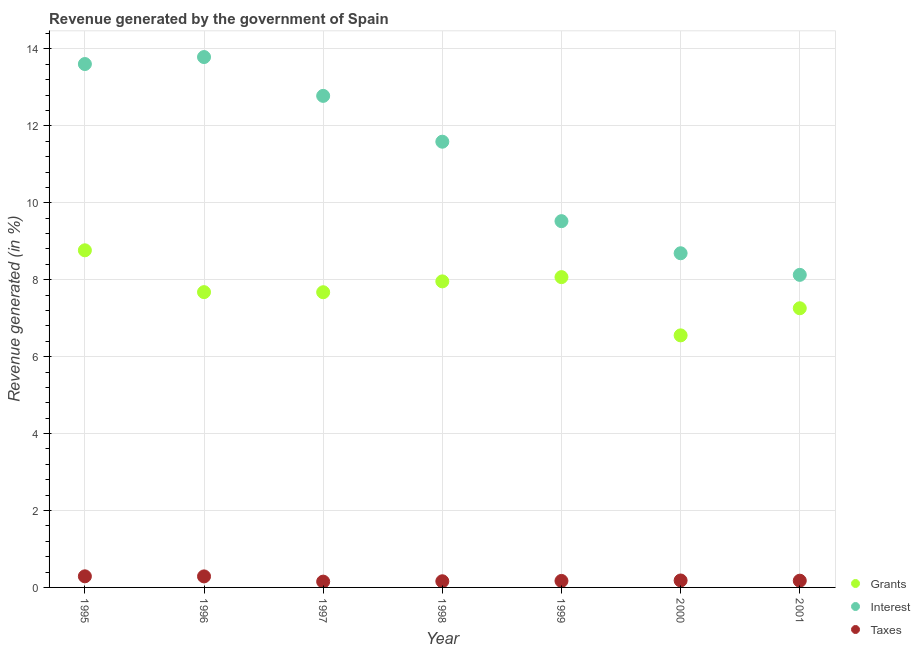How many different coloured dotlines are there?
Your response must be concise. 3. Is the number of dotlines equal to the number of legend labels?
Your answer should be very brief. Yes. What is the percentage of revenue generated by grants in 1998?
Give a very brief answer. 7.96. Across all years, what is the maximum percentage of revenue generated by taxes?
Offer a terse response. 0.29. Across all years, what is the minimum percentage of revenue generated by interest?
Your response must be concise. 8.13. In which year was the percentage of revenue generated by grants maximum?
Make the answer very short. 1995. What is the total percentage of revenue generated by interest in the graph?
Keep it short and to the point. 78.1. What is the difference between the percentage of revenue generated by taxes in 1995 and that in 1997?
Keep it short and to the point. 0.14. What is the difference between the percentage of revenue generated by taxes in 2000 and the percentage of revenue generated by grants in 1998?
Provide a succinct answer. -7.78. What is the average percentage of revenue generated by grants per year?
Your answer should be very brief. 7.71. In the year 1999, what is the difference between the percentage of revenue generated by taxes and percentage of revenue generated by grants?
Your answer should be very brief. -7.9. In how many years, is the percentage of revenue generated by interest greater than 9.2 %?
Your response must be concise. 5. What is the ratio of the percentage of revenue generated by grants in 1995 to that in 1996?
Provide a short and direct response. 1.14. What is the difference between the highest and the second highest percentage of revenue generated by grants?
Your answer should be very brief. 0.7. What is the difference between the highest and the lowest percentage of revenue generated by interest?
Give a very brief answer. 5.66. In how many years, is the percentage of revenue generated by interest greater than the average percentage of revenue generated by interest taken over all years?
Provide a short and direct response. 4. Is the sum of the percentage of revenue generated by taxes in 1997 and 2000 greater than the maximum percentage of revenue generated by interest across all years?
Offer a terse response. No. Does the percentage of revenue generated by grants monotonically increase over the years?
Your answer should be very brief. No. How many years are there in the graph?
Keep it short and to the point. 7. Are the values on the major ticks of Y-axis written in scientific E-notation?
Offer a very short reply. No. Does the graph contain grids?
Your answer should be compact. Yes. Where does the legend appear in the graph?
Give a very brief answer. Bottom right. How many legend labels are there?
Give a very brief answer. 3. What is the title of the graph?
Offer a terse response. Revenue generated by the government of Spain. What is the label or title of the X-axis?
Your answer should be compact. Year. What is the label or title of the Y-axis?
Provide a succinct answer. Revenue generated (in %). What is the Revenue generated (in %) in Grants in 1995?
Offer a very short reply. 8.77. What is the Revenue generated (in %) of Interest in 1995?
Your answer should be very brief. 13.61. What is the Revenue generated (in %) of Taxes in 1995?
Make the answer very short. 0.29. What is the Revenue generated (in %) of Grants in 1996?
Give a very brief answer. 7.68. What is the Revenue generated (in %) of Interest in 1996?
Make the answer very short. 13.79. What is the Revenue generated (in %) of Taxes in 1996?
Provide a short and direct response. 0.29. What is the Revenue generated (in %) of Grants in 1997?
Give a very brief answer. 7.67. What is the Revenue generated (in %) of Interest in 1997?
Offer a terse response. 12.78. What is the Revenue generated (in %) of Taxes in 1997?
Offer a very short reply. 0.15. What is the Revenue generated (in %) in Grants in 1998?
Give a very brief answer. 7.96. What is the Revenue generated (in %) in Interest in 1998?
Offer a very short reply. 11.59. What is the Revenue generated (in %) in Taxes in 1998?
Your response must be concise. 0.16. What is the Revenue generated (in %) of Grants in 1999?
Your answer should be very brief. 8.07. What is the Revenue generated (in %) of Interest in 1999?
Ensure brevity in your answer.  9.52. What is the Revenue generated (in %) of Taxes in 1999?
Your response must be concise. 0.17. What is the Revenue generated (in %) of Grants in 2000?
Your answer should be very brief. 6.55. What is the Revenue generated (in %) of Interest in 2000?
Keep it short and to the point. 8.69. What is the Revenue generated (in %) of Taxes in 2000?
Ensure brevity in your answer.  0.18. What is the Revenue generated (in %) of Grants in 2001?
Give a very brief answer. 7.26. What is the Revenue generated (in %) of Interest in 2001?
Give a very brief answer. 8.13. What is the Revenue generated (in %) of Taxes in 2001?
Give a very brief answer. 0.17. Across all years, what is the maximum Revenue generated (in %) of Grants?
Offer a very short reply. 8.77. Across all years, what is the maximum Revenue generated (in %) in Interest?
Your answer should be very brief. 13.79. Across all years, what is the maximum Revenue generated (in %) in Taxes?
Provide a short and direct response. 0.29. Across all years, what is the minimum Revenue generated (in %) of Grants?
Offer a terse response. 6.55. Across all years, what is the minimum Revenue generated (in %) of Interest?
Your answer should be very brief. 8.13. Across all years, what is the minimum Revenue generated (in %) of Taxes?
Offer a terse response. 0.15. What is the total Revenue generated (in %) of Grants in the graph?
Provide a succinct answer. 53.95. What is the total Revenue generated (in %) in Interest in the graph?
Your answer should be very brief. 78.1. What is the total Revenue generated (in %) of Taxes in the graph?
Your answer should be very brief. 1.41. What is the difference between the Revenue generated (in %) of Grants in 1995 and that in 1996?
Give a very brief answer. 1.09. What is the difference between the Revenue generated (in %) of Interest in 1995 and that in 1996?
Your response must be concise. -0.18. What is the difference between the Revenue generated (in %) of Taxes in 1995 and that in 1996?
Provide a short and direct response. 0. What is the difference between the Revenue generated (in %) of Grants in 1995 and that in 1997?
Offer a terse response. 1.09. What is the difference between the Revenue generated (in %) of Interest in 1995 and that in 1997?
Your answer should be compact. 0.83. What is the difference between the Revenue generated (in %) in Taxes in 1995 and that in 1997?
Your response must be concise. 0.14. What is the difference between the Revenue generated (in %) in Grants in 1995 and that in 1998?
Ensure brevity in your answer.  0.81. What is the difference between the Revenue generated (in %) of Interest in 1995 and that in 1998?
Offer a very short reply. 2.02. What is the difference between the Revenue generated (in %) of Taxes in 1995 and that in 1998?
Your answer should be compact. 0.13. What is the difference between the Revenue generated (in %) in Grants in 1995 and that in 1999?
Keep it short and to the point. 0.7. What is the difference between the Revenue generated (in %) of Interest in 1995 and that in 1999?
Make the answer very short. 4.08. What is the difference between the Revenue generated (in %) in Taxes in 1995 and that in 1999?
Provide a succinct answer. 0.12. What is the difference between the Revenue generated (in %) in Grants in 1995 and that in 2000?
Your answer should be compact. 2.21. What is the difference between the Revenue generated (in %) of Interest in 1995 and that in 2000?
Ensure brevity in your answer.  4.92. What is the difference between the Revenue generated (in %) of Taxes in 1995 and that in 2000?
Keep it short and to the point. 0.11. What is the difference between the Revenue generated (in %) of Grants in 1995 and that in 2001?
Offer a terse response. 1.51. What is the difference between the Revenue generated (in %) of Interest in 1995 and that in 2001?
Ensure brevity in your answer.  5.48. What is the difference between the Revenue generated (in %) of Taxes in 1995 and that in 2001?
Keep it short and to the point. 0.11. What is the difference between the Revenue generated (in %) in Grants in 1996 and that in 1997?
Ensure brevity in your answer.  0. What is the difference between the Revenue generated (in %) of Interest in 1996 and that in 1997?
Offer a very short reply. 1.01. What is the difference between the Revenue generated (in %) in Taxes in 1996 and that in 1997?
Make the answer very short. 0.14. What is the difference between the Revenue generated (in %) of Grants in 1996 and that in 1998?
Ensure brevity in your answer.  -0.28. What is the difference between the Revenue generated (in %) in Interest in 1996 and that in 1998?
Your answer should be compact. 2.2. What is the difference between the Revenue generated (in %) of Taxes in 1996 and that in 1998?
Offer a terse response. 0.13. What is the difference between the Revenue generated (in %) in Grants in 1996 and that in 1999?
Provide a succinct answer. -0.39. What is the difference between the Revenue generated (in %) of Interest in 1996 and that in 1999?
Offer a very short reply. 4.27. What is the difference between the Revenue generated (in %) in Taxes in 1996 and that in 1999?
Your response must be concise. 0.12. What is the difference between the Revenue generated (in %) in Grants in 1996 and that in 2000?
Your answer should be very brief. 1.12. What is the difference between the Revenue generated (in %) in Interest in 1996 and that in 2000?
Offer a terse response. 5.1. What is the difference between the Revenue generated (in %) of Taxes in 1996 and that in 2000?
Ensure brevity in your answer.  0.11. What is the difference between the Revenue generated (in %) of Grants in 1996 and that in 2001?
Ensure brevity in your answer.  0.42. What is the difference between the Revenue generated (in %) in Interest in 1996 and that in 2001?
Give a very brief answer. 5.66. What is the difference between the Revenue generated (in %) in Taxes in 1996 and that in 2001?
Ensure brevity in your answer.  0.11. What is the difference between the Revenue generated (in %) of Grants in 1997 and that in 1998?
Your answer should be compact. -0.28. What is the difference between the Revenue generated (in %) in Interest in 1997 and that in 1998?
Offer a very short reply. 1.19. What is the difference between the Revenue generated (in %) of Taxes in 1997 and that in 1998?
Keep it short and to the point. -0.01. What is the difference between the Revenue generated (in %) of Grants in 1997 and that in 1999?
Your answer should be very brief. -0.39. What is the difference between the Revenue generated (in %) of Interest in 1997 and that in 1999?
Ensure brevity in your answer.  3.26. What is the difference between the Revenue generated (in %) of Taxes in 1997 and that in 1999?
Your answer should be compact. -0.02. What is the difference between the Revenue generated (in %) of Grants in 1997 and that in 2000?
Your answer should be very brief. 1.12. What is the difference between the Revenue generated (in %) in Interest in 1997 and that in 2000?
Provide a succinct answer. 4.09. What is the difference between the Revenue generated (in %) in Taxes in 1997 and that in 2000?
Ensure brevity in your answer.  -0.03. What is the difference between the Revenue generated (in %) in Grants in 1997 and that in 2001?
Give a very brief answer. 0.42. What is the difference between the Revenue generated (in %) in Interest in 1997 and that in 2001?
Make the answer very short. 4.65. What is the difference between the Revenue generated (in %) of Taxes in 1997 and that in 2001?
Provide a succinct answer. -0.02. What is the difference between the Revenue generated (in %) of Grants in 1998 and that in 1999?
Your answer should be very brief. -0.11. What is the difference between the Revenue generated (in %) of Interest in 1998 and that in 1999?
Offer a terse response. 2.07. What is the difference between the Revenue generated (in %) of Taxes in 1998 and that in 1999?
Ensure brevity in your answer.  -0.01. What is the difference between the Revenue generated (in %) of Grants in 1998 and that in 2000?
Your answer should be very brief. 1.4. What is the difference between the Revenue generated (in %) of Interest in 1998 and that in 2000?
Keep it short and to the point. 2.9. What is the difference between the Revenue generated (in %) in Taxes in 1998 and that in 2000?
Offer a very short reply. -0.02. What is the difference between the Revenue generated (in %) of Grants in 1998 and that in 2001?
Make the answer very short. 0.7. What is the difference between the Revenue generated (in %) of Interest in 1998 and that in 2001?
Give a very brief answer. 3.46. What is the difference between the Revenue generated (in %) in Taxes in 1998 and that in 2001?
Your response must be concise. -0.01. What is the difference between the Revenue generated (in %) in Grants in 1999 and that in 2000?
Ensure brevity in your answer.  1.51. What is the difference between the Revenue generated (in %) in Interest in 1999 and that in 2000?
Provide a short and direct response. 0.83. What is the difference between the Revenue generated (in %) in Taxes in 1999 and that in 2000?
Your response must be concise. -0.01. What is the difference between the Revenue generated (in %) in Grants in 1999 and that in 2001?
Offer a very short reply. 0.81. What is the difference between the Revenue generated (in %) in Interest in 1999 and that in 2001?
Offer a very short reply. 1.4. What is the difference between the Revenue generated (in %) in Taxes in 1999 and that in 2001?
Your answer should be compact. -0.01. What is the difference between the Revenue generated (in %) in Grants in 2000 and that in 2001?
Ensure brevity in your answer.  -0.7. What is the difference between the Revenue generated (in %) of Interest in 2000 and that in 2001?
Keep it short and to the point. 0.56. What is the difference between the Revenue generated (in %) in Taxes in 2000 and that in 2001?
Provide a succinct answer. 0.01. What is the difference between the Revenue generated (in %) in Grants in 1995 and the Revenue generated (in %) in Interest in 1996?
Offer a very short reply. -5.02. What is the difference between the Revenue generated (in %) of Grants in 1995 and the Revenue generated (in %) of Taxes in 1996?
Your answer should be very brief. 8.48. What is the difference between the Revenue generated (in %) in Interest in 1995 and the Revenue generated (in %) in Taxes in 1996?
Your answer should be compact. 13.32. What is the difference between the Revenue generated (in %) of Grants in 1995 and the Revenue generated (in %) of Interest in 1997?
Your answer should be compact. -4.02. What is the difference between the Revenue generated (in %) of Grants in 1995 and the Revenue generated (in %) of Taxes in 1997?
Provide a succinct answer. 8.61. What is the difference between the Revenue generated (in %) in Interest in 1995 and the Revenue generated (in %) in Taxes in 1997?
Your response must be concise. 13.46. What is the difference between the Revenue generated (in %) of Grants in 1995 and the Revenue generated (in %) of Interest in 1998?
Your response must be concise. -2.82. What is the difference between the Revenue generated (in %) of Grants in 1995 and the Revenue generated (in %) of Taxes in 1998?
Offer a very short reply. 8.6. What is the difference between the Revenue generated (in %) in Interest in 1995 and the Revenue generated (in %) in Taxes in 1998?
Provide a succinct answer. 13.45. What is the difference between the Revenue generated (in %) of Grants in 1995 and the Revenue generated (in %) of Interest in 1999?
Your response must be concise. -0.76. What is the difference between the Revenue generated (in %) in Grants in 1995 and the Revenue generated (in %) in Taxes in 1999?
Give a very brief answer. 8.6. What is the difference between the Revenue generated (in %) in Interest in 1995 and the Revenue generated (in %) in Taxes in 1999?
Provide a short and direct response. 13.44. What is the difference between the Revenue generated (in %) of Grants in 1995 and the Revenue generated (in %) of Interest in 2000?
Your response must be concise. 0.08. What is the difference between the Revenue generated (in %) in Grants in 1995 and the Revenue generated (in %) in Taxes in 2000?
Make the answer very short. 8.58. What is the difference between the Revenue generated (in %) of Interest in 1995 and the Revenue generated (in %) of Taxes in 2000?
Keep it short and to the point. 13.43. What is the difference between the Revenue generated (in %) of Grants in 1995 and the Revenue generated (in %) of Interest in 2001?
Offer a very short reply. 0.64. What is the difference between the Revenue generated (in %) in Grants in 1995 and the Revenue generated (in %) in Taxes in 2001?
Provide a succinct answer. 8.59. What is the difference between the Revenue generated (in %) of Interest in 1995 and the Revenue generated (in %) of Taxes in 2001?
Your answer should be very brief. 13.43. What is the difference between the Revenue generated (in %) of Grants in 1996 and the Revenue generated (in %) of Interest in 1997?
Provide a succinct answer. -5.1. What is the difference between the Revenue generated (in %) in Grants in 1996 and the Revenue generated (in %) in Taxes in 1997?
Keep it short and to the point. 7.53. What is the difference between the Revenue generated (in %) of Interest in 1996 and the Revenue generated (in %) of Taxes in 1997?
Make the answer very short. 13.64. What is the difference between the Revenue generated (in %) in Grants in 1996 and the Revenue generated (in %) in Interest in 1998?
Your answer should be very brief. -3.91. What is the difference between the Revenue generated (in %) in Grants in 1996 and the Revenue generated (in %) in Taxes in 1998?
Offer a very short reply. 7.52. What is the difference between the Revenue generated (in %) in Interest in 1996 and the Revenue generated (in %) in Taxes in 1998?
Make the answer very short. 13.63. What is the difference between the Revenue generated (in %) of Grants in 1996 and the Revenue generated (in %) of Interest in 1999?
Your response must be concise. -1.85. What is the difference between the Revenue generated (in %) of Grants in 1996 and the Revenue generated (in %) of Taxes in 1999?
Keep it short and to the point. 7.51. What is the difference between the Revenue generated (in %) in Interest in 1996 and the Revenue generated (in %) in Taxes in 1999?
Your answer should be very brief. 13.62. What is the difference between the Revenue generated (in %) of Grants in 1996 and the Revenue generated (in %) of Interest in 2000?
Give a very brief answer. -1.01. What is the difference between the Revenue generated (in %) in Grants in 1996 and the Revenue generated (in %) in Taxes in 2000?
Offer a very short reply. 7.5. What is the difference between the Revenue generated (in %) in Interest in 1996 and the Revenue generated (in %) in Taxes in 2000?
Offer a terse response. 13.61. What is the difference between the Revenue generated (in %) of Grants in 1996 and the Revenue generated (in %) of Interest in 2001?
Make the answer very short. -0.45. What is the difference between the Revenue generated (in %) of Grants in 1996 and the Revenue generated (in %) of Taxes in 2001?
Your response must be concise. 7.5. What is the difference between the Revenue generated (in %) in Interest in 1996 and the Revenue generated (in %) in Taxes in 2001?
Your answer should be very brief. 13.61. What is the difference between the Revenue generated (in %) in Grants in 1997 and the Revenue generated (in %) in Interest in 1998?
Your answer should be very brief. -3.91. What is the difference between the Revenue generated (in %) in Grants in 1997 and the Revenue generated (in %) in Taxes in 1998?
Provide a succinct answer. 7.51. What is the difference between the Revenue generated (in %) in Interest in 1997 and the Revenue generated (in %) in Taxes in 1998?
Give a very brief answer. 12.62. What is the difference between the Revenue generated (in %) of Grants in 1997 and the Revenue generated (in %) of Interest in 1999?
Make the answer very short. -1.85. What is the difference between the Revenue generated (in %) of Grants in 1997 and the Revenue generated (in %) of Taxes in 1999?
Provide a succinct answer. 7.51. What is the difference between the Revenue generated (in %) in Interest in 1997 and the Revenue generated (in %) in Taxes in 1999?
Offer a very short reply. 12.61. What is the difference between the Revenue generated (in %) of Grants in 1997 and the Revenue generated (in %) of Interest in 2000?
Provide a short and direct response. -1.01. What is the difference between the Revenue generated (in %) of Grants in 1997 and the Revenue generated (in %) of Taxes in 2000?
Provide a succinct answer. 7.49. What is the difference between the Revenue generated (in %) of Interest in 1997 and the Revenue generated (in %) of Taxes in 2000?
Your answer should be very brief. 12.6. What is the difference between the Revenue generated (in %) in Grants in 1997 and the Revenue generated (in %) in Interest in 2001?
Offer a very short reply. -0.45. What is the difference between the Revenue generated (in %) of Grants in 1997 and the Revenue generated (in %) of Taxes in 2001?
Your answer should be very brief. 7.5. What is the difference between the Revenue generated (in %) in Interest in 1997 and the Revenue generated (in %) in Taxes in 2001?
Make the answer very short. 12.61. What is the difference between the Revenue generated (in %) of Grants in 1998 and the Revenue generated (in %) of Interest in 1999?
Make the answer very short. -1.57. What is the difference between the Revenue generated (in %) of Grants in 1998 and the Revenue generated (in %) of Taxes in 1999?
Make the answer very short. 7.79. What is the difference between the Revenue generated (in %) of Interest in 1998 and the Revenue generated (in %) of Taxes in 1999?
Ensure brevity in your answer.  11.42. What is the difference between the Revenue generated (in %) in Grants in 1998 and the Revenue generated (in %) in Interest in 2000?
Provide a succinct answer. -0.73. What is the difference between the Revenue generated (in %) in Grants in 1998 and the Revenue generated (in %) in Taxes in 2000?
Provide a succinct answer. 7.78. What is the difference between the Revenue generated (in %) of Interest in 1998 and the Revenue generated (in %) of Taxes in 2000?
Your response must be concise. 11.41. What is the difference between the Revenue generated (in %) in Grants in 1998 and the Revenue generated (in %) in Interest in 2001?
Make the answer very short. -0.17. What is the difference between the Revenue generated (in %) of Grants in 1998 and the Revenue generated (in %) of Taxes in 2001?
Your answer should be very brief. 7.78. What is the difference between the Revenue generated (in %) in Interest in 1998 and the Revenue generated (in %) in Taxes in 2001?
Make the answer very short. 11.41. What is the difference between the Revenue generated (in %) in Grants in 1999 and the Revenue generated (in %) in Interest in 2000?
Offer a very short reply. -0.62. What is the difference between the Revenue generated (in %) of Grants in 1999 and the Revenue generated (in %) of Taxes in 2000?
Give a very brief answer. 7.89. What is the difference between the Revenue generated (in %) of Interest in 1999 and the Revenue generated (in %) of Taxes in 2000?
Provide a short and direct response. 9.34. What is the difference between the Revenue generated (in %) of Grants in 1999 and the Revenue generated (in %) of Interest in 2001?
Your answer should be very brief. -0.06. What is the difference between the Revenue generated (in %) of Grants in 1999 and the Revenue generated (in %) of Taxes in 2001?
Make the answer very short. 7.89. What is the difference between the Revenue generated (in %) of Interest in 1999 and the Revenue generated (in %) of Taxes in 2001?
Your response must be concise. 9.35. What is the difference between the Revenue generated (in %) in Grants in 2000 and the Revenue generated (in %) in Interest in 2001?
Your answer should be compact. -1.57. What is the difference between the Revenue generated (in %) of Grants in 2000 and the Revenue generated (in %) of Taxes in 2001?
Your answer should be compact. 6.38. What is the difference between the Revenue generated (in %) of Interest in 2000 and the Revenue generated (in %) of Taxes in 2001?
Offer a very short reply. 8.51. What is the average Revenue generated (in %) of Grants per year?
Offer a terse response. 7.71. What is the average Revenue generated (in %) of Interest per year?
Provide a succinct answer. 11.16. What is the average Revenue generated (in %) in Taxes per year?
Provide a succinct answer. 0.2. In the year 1995, what is the difference between the Revenue generated (in %) of Grants and Revenue generated (in %) of Interest?
Give a very brief answer. -4.84. In the year 1995, what is the difference between the Revenue generated (in %) in Grants and Revenue generated (in %) in Taxes?
Provide a short and direct response. 8.48. In the year 1995, what is the difference between the Revenue generated (in %) of Interest and Revenue generated (in %) of Taxes?
Offer a very short reply. 13.32. In the year 1996, what is the difference between the Revenue generated (in %) of Grants and Revenue generated (in %) of Interest?
Offer a terse response. -6.11. In the year 1996, what is the difference between the Revenue generated (in %) in Grants and Revenue generated (in %) in Taxes?
Offer a very short reply. 7.39. In the year 1996, what is the difference between the Revenue generated (in %) in Interest and Revenue generated (in %) in Taxes?
Offer a very short reply. 13.5. In the year 1997, what is the difference between the Revenue generated (in %) in Grants and Revenue generated (in %) in Interest?
Provide a succinct answer. -5.11. In the year 1997, what is the difference between the Revenue generated (in %) in Grants and Revenue generated (in %) in Taxes?
Give a very brief answer. 7.52. In the year 1997, what is the difference between the Revenue generated (in %) of Interest and Revenue generated (in %) of Taxes?
Give a very brief answer. 12.63. In the year 1998, what is the difference between the Revenue generated (in %) in Grants and Revenue generated (in %) in Interest?
Give a very brief answer. -3.63. In the year 1998, what is the difference between the Revenue generated (in %) of Grants and Revenue generated (in %) of Taxes?
Provide a succinct answer. 7.8. In the year 1998, what is the difference between the Revenue generated (in %) of Interest and Revenue generated (in %) of Taxes?
Offer a terse response. 11.43. In the year 1999, what is the difference between the Revenue generated (in %) in Grants and Revenue generated (in %) in Interest?
Your response must be concise. -1.46. In the year 1999, what is the difference between the Revenue generated (in %) in Grants and Revenue generated (in %) in Taxes?
Keep it short and to the point. 7.9. In the year 1999, what is the difference between the Revenue generated (in %) in Interest and Revenue generated (in %) in Taxes?
Ensure brevity in your answer.  9.35. In the year 2000, what is the difference between the Revenue generated (in %) in Grants and Revenue generated (in %) in Interest?
Your answer should be compact. -2.13. In the year 2000, what is the difference between the Revenue generated (in %) in Grants and Revenue generated (in %) in Taxes?
Your answer should be very brief. 6.37. In the year 2000, what is the difference between the Revenue generated (in %) of Interest and Revenue generated (in %) of Taxes?
Provide a short and direct response. 8.51. In the year 2001, what is the difference between the Revenue generated (in %) in Grants and Revenue generated (in %) in Interest?
Keep it short and to the point. -0.87. In the year 2001, what is the difference between the Revenue generated (in %) of Grants and Revenue generated (in %) of Taxes?
Provide a short and direct response. 7.08. In the year 2001, what is the difference between the Revenue generated (in %) of Interest and Revenue generated (in %) of Taxes?
Offer a very short reply. 7.95. What is the ratio of the Revenue generated (in %) in Grants in 1995 to that in 1996?
Give a very brief answer. 1.14. What is the ratio of the Revenue generated (in %) of Taxes in 1995 to that in 1996?
Offer a very short reply. 1.01. What is the ratio of the Revenue generated (in %) in Grants in 1995 to that in 1997?
Your answer should be very brief. 1.14. What is the ratio of the Revenue generated (in %) of Interest in 1995 to that in 1997?
Provide a succinct answer. 1.06. What is the ratio of the Revenue generated (in %) in Taxes in 1995 to that in 1997?
Make the answer very short. 1.91. What is the ratio of the Revenue generated (in %) of Grants in 1995 to that in 1998?
Keep it short and to the point. 1.1. What is the ratio of the Revenue generated (in %) in Interest in 1995 to that in 1998?
Offer a terse response. 1.17. What is the ratio of the Revenue generated (in %) in Taxes in 1995 to that in 1998?
Your response must be concise. 1.8. What is the ratio of the Revenue generated (in %) of Grants in 1995 to that in 1999?
Keep it short and to the point. 1.09. What is the ratio of the Revenue generated (in %) in Interest in 1995 to that in 1999?
Give a very brief answer. 1.43. What is the ratio of the Revenue generated (in %) in Taxes in 1995 to that in 1999?
Keep it short and to the point. 1.71. What is the ratio of the Revenue generated (in %) of Grants in 1995 to that in 2000?
Your response must be concise. 1.34. What is the ratio of the Revenue generated (in %) of Interest in 1995 to that in 2000?
Your answer should be compact. 1.57. What is the ratio of the Revenue generated (in %) of Taxes in 1995 to that in 2000?
Your answer should be very brief. 1.6. What is the ratio of the Revenue generated (in %) of Grants in 1995 to that in 2001?
Offer a very short reply. 1.21. What is the ratio of the Revenue generated (in %) in Interest in 1995 to that in 2001?
Offer a terse response. 1.67. What is the ratio of the Revenue generated (in %) in Taxes in 1995 to that in 2001?
Provide a short and direct response. 1.65. What is the ratio of the Revenue generated (in %) in Grants in 1996 to that in 1997?
Your answer should be very brief. 1. What is the ratio of the Revenue generated (in %) in Interest in 1996 to that in 1997?
Provide a short and direct response. 1.08. What is the ratio of the Revenue generated (in %) in Taxes in 1996 to that in 1997?
Provide a succinct answer. 1.9. What is the ratio of the Revenue generated (in %) of Grants in 1996 to that in 1998?
Ensure brevity in your answer.  0.96. What is the ratio of the Revenue generated (in %) in Interest in 1996 to that in 1998?
Your answer should be compact. 1.19. What is the ratio of the Revenue generated (in %) of Taxes in 1996 to that in 1998?
Give a very brief answer. 1.79. What is the ratio of the Revenue generated (in %) of Grants in 1996 to that in 1999?
Your response must be concise. 0.95. What is the ratio of the Revenue generated (in %) of Interest in 1996 to that in 1999?
Your response must be concise. 1.45. What is the ratio of the Revenue generated (in %) in Taxes in 1996 to that in 1999?
Make the answer very short. 1.7. What is the ratio of the Revenue generated (in %) in Grants in 1996 to that in 2000?
Make the answer very short. 1.17. What is the ratio of the Revenue generated (in %) of Interest in 1996 to that in 2000?
Ensure brevity in your answer.  1.59. What is the ratio of the Revenue generated (in %) of Taxes in 1996 to that in 2000?
Provide a short and direct response. 1.59. What is the ratio of the Revenue generated (in %) of Grants in 1996 to that in 2001?
Keep it short and to the point. 1.06. What is the ratio of the Revenue generated (in %) in Interest in 1996 to that in 2001?
Your answer should be very brief. 1.7. What is the ratio of the Revenue generated (in %) in Taxes in 1996 to that in 2001?
Make the answer very short. 1.64. What is the ratio of the Revenue generated (in %) of Grants in 1997 to that in 1998?
Make the answer very short. 0.96. What is the ratio of the Revenue generated (in %) in Interest in 1997 to that in 1998?
Provide a succinct answer. 1.1. What is the ratio of the Revenue generated (in %) of Taxes in 1997 to that in 1998?
Your answer should be compact. 0.94. What is the ratio of the Revenue generated (in %) of Grants in 1997 to that in 1999?
Ensure brevity in your answer.  0.95. What is the ratio of the Revenue generated (in %) in Interest in 1997 to that in 1999?
Offer a very short reply. 1.34. What is the ratio of the Revenue generated (in %) of Taxes in 1997 to that in 1999?
Make the answer very short. 0.89. What is the ratio of the Revenue generated (in %) in Grants in 1997 to that in 2000?
Your response must be concise. 1.17. What is the ratio of the Revenue generated (in %) in Interest in 1997 to that in 2000?
Provide a succinct answer. 1.47. What is the ratio of the Revenue generated (in %) of Taxes in 1997 to that in 2000?
Give a very brief answer. 0.84. What is the ratio of the Revenue generated (in %) of Grants in 1997 to that in 2001?
Your answer should be very brief. 1.06. What is the ratio of the Revenue generated (in %) of Interest in 1997 to that in 2001?
Offer a very short reply. 1.57. What is the ratio of the Revenue generated (in %) of Taxes in 1997 to that in 2001?
Your response must be concise. 0.86. What is the ratio of the Revenue generated (in %) in Grants in 1998 to that in 1999?
Ensure brevity in your answer.  0.99. What is the ratio of the Revenue generated (in %) of Interest in 1998 to that in 1999?
Make the answer very short. 1.22. What is the ratio of the Revenue generated (in %) in Taxes in 1998 to that in 1999?
Provide a short and direct response. 0.95. What is the ratio of the Revenue generated (in %) of Grants in 1998 to that in 2000?
Your response must be concise. 1.21. What is the ratio of the Revenue generated (in %) in Interest in 1998 to that in 2000?
Provide a short and direct response. 1.33. What is the ratio of the Revenue generated (in %) of Taxes in 1998 to that in 2000?
Provide a short and direct response. 0.89. What is the ratio of the Revenue generated (in %) in Grants in 1998 to that in 2001?
Your response must be concise. 1.1. What is the ratio of the Revenue generated (in %) in Interest in 1998 to that in 2001?
Provide a short and direct response. 1.43. What is the ratio of the Revenue generated (in %) of Taxes in 1998 to that in 2001?
Offer a very short reply. 0.92. What is the ratio of the Revenue generated (in %) of Grants in 1999 to that in 2000?
Offer a terse response. 1.23. What is the ratio of the Revenue generated (in %) in Interest in 1999 to that in 2000?
Offer a terse response. 1.1. What is the ratio of the Revenue generated (in %) of Taxes in 1999 to that in 2000?
Your response must be concise. 0.93. What is the ratio of the Revenue generated (in %) in Grants in 1999 to that in 2001?
Ensure brevity in your answer.  1.11. What is the ratio of the Revenue generated (in %) in Interest in 1999 to that in 2001?
Your response must be concise. 1.17. What is the ratio of the Revenue generated (in %) of Grants in 2000 to that in 2001?
Make the answer very short. 0.9. What is the ratio of the Revenue generated (in %) in Interest in 2000 to that in 2001?
Offer a terse response. 1.07. What is the ratio of the Revenue generated (in %) in Taxes in 2000 to that in 2001?
Your response must be concise. 1.03. What is the difference between the highest and the second highest Revenue generated (in %) of Grants?
Offer a very short reply. 0.7. What is the difference between the highest and the second highest Revenue generated (in %) of Interest?
Offer a terse response. 0.18. What is the difference between the highest and the second highest Revenue generated (in %) of Taxes?
Give a very brief answer. 0. What is the difference between the highest and the lowest Revenue generated (in %) in Grants?
Offer a terse response. 2.21. What is the difference between the highest and the lowest Revenue generated (in %) of Interest?
Your answer should be compact. 5.66. What is the difference between the highest and the lowest Revenue generated (in %) of Taxes?
Ensure brevity in your answer.  0.14. 